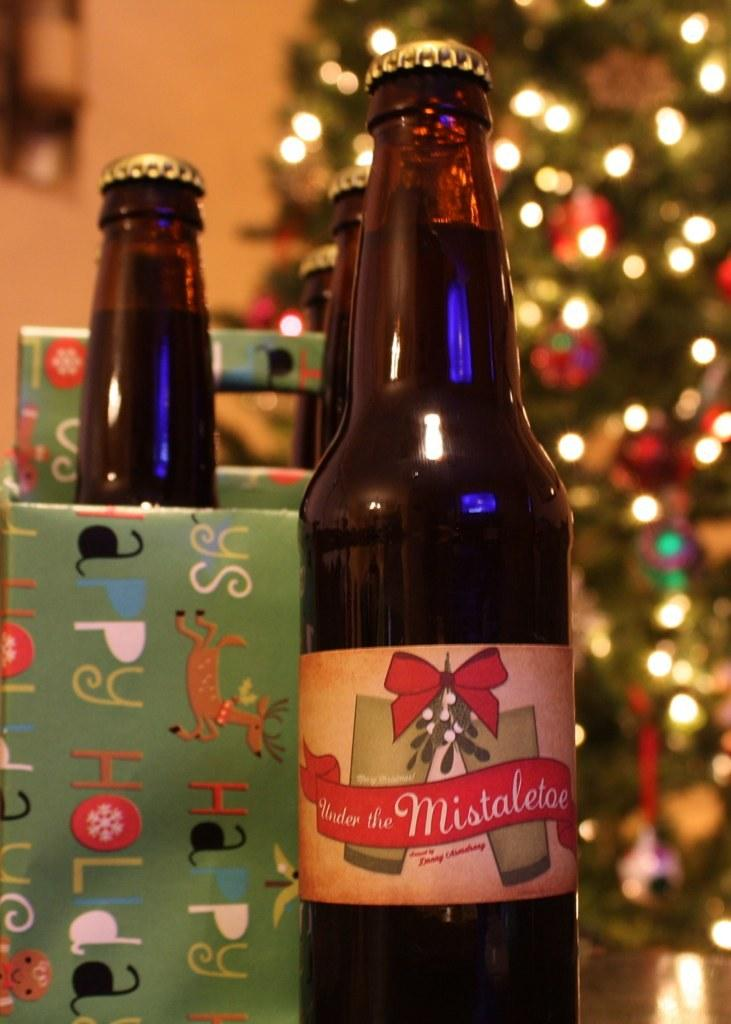<image>
Summarize the visual content of the image. A bottle of Under the Miseltoe beer sits in front of a christmas tree. 